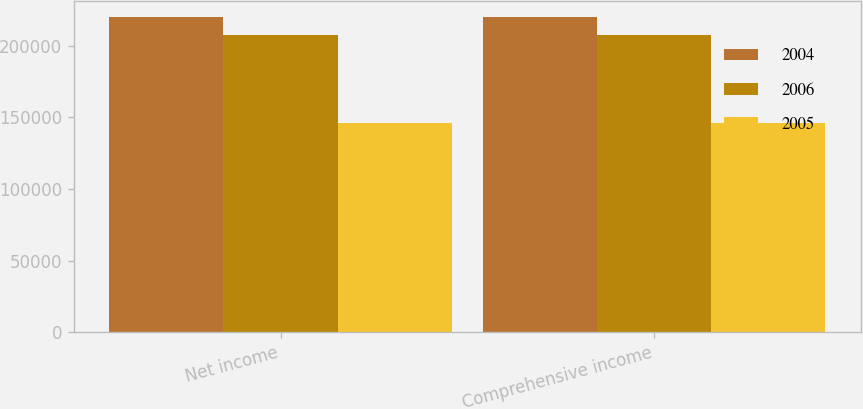<chart> <loc_0><loc_0><loc_500><loc_500><stacked_bar_chart><ecel><fcel>Net income<fcel>Comprehensive income<nl><fcel>2004<fcel>219952<fcel>219804<nl><fcel>2006<fcel>207311<fcel>207311<nl><fcel>2005<fcel>146256<fcel>146256<nl></chart> 